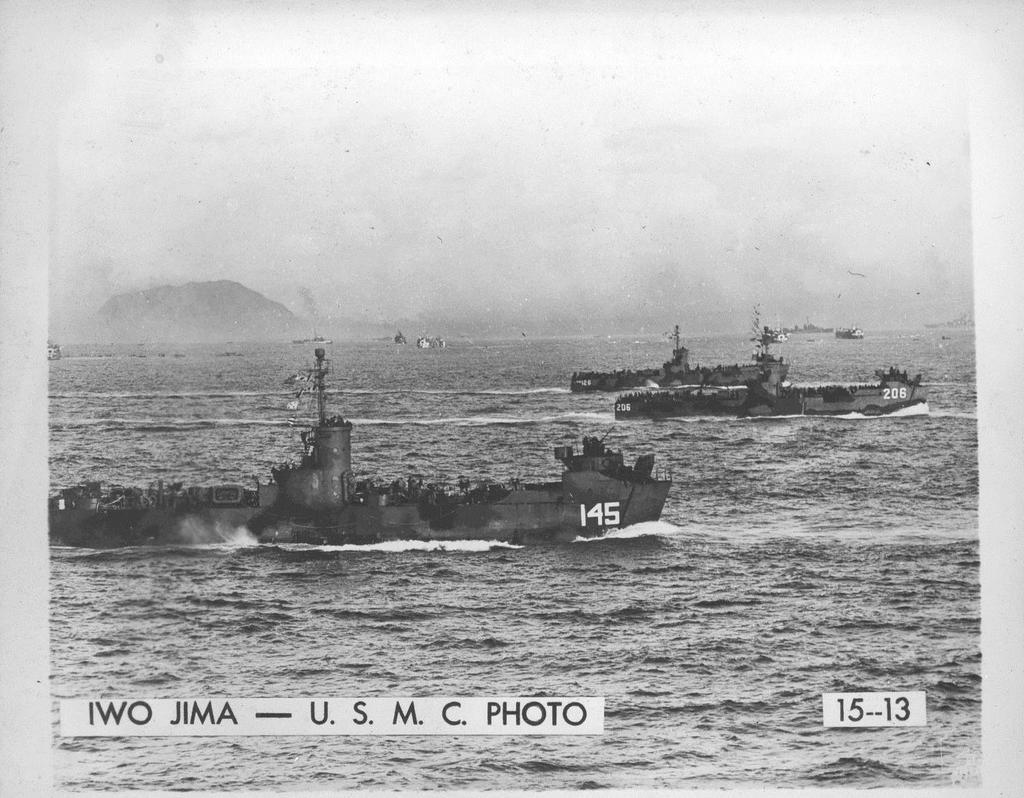<image>
Render a clear and concise summary of the photo. A black and white picture of Iwo Jima taken by the USMC. 